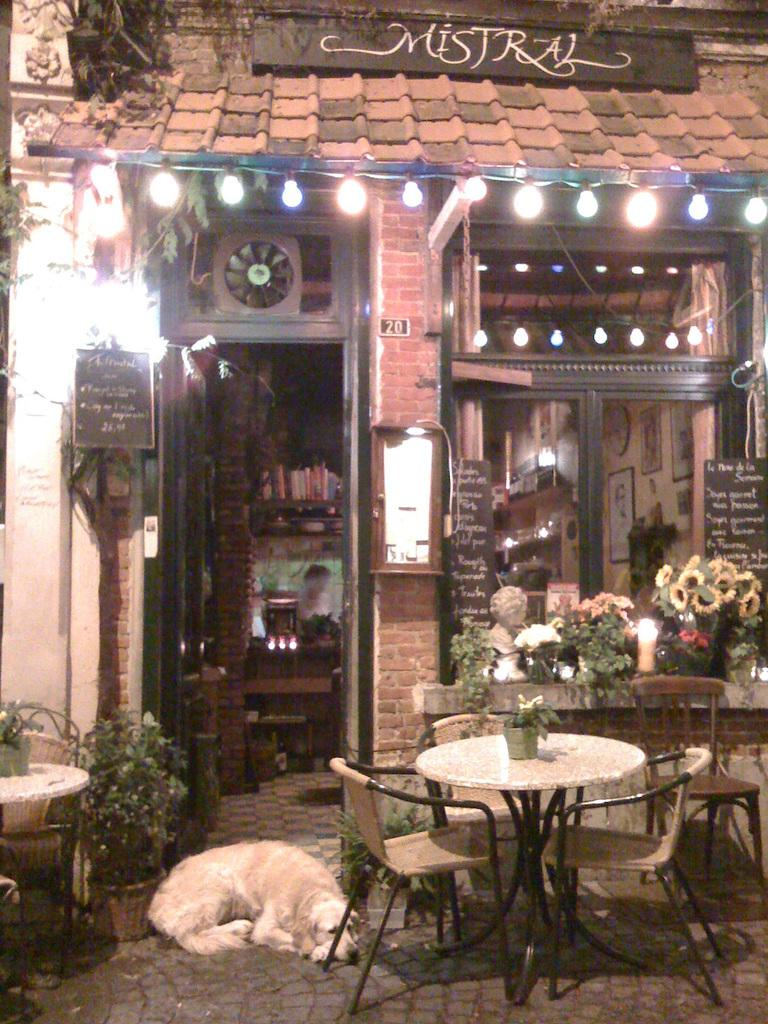What type of establishment is shown in the image? A: There is a store in the image. What furniture is available inside the store? The store has tables and chairs. What is the store's flooring like? The store has floors. Is there any animal present in the image? Yes, there is a dog sleeping in front of the store's door. What type of hose is being used to water the plants in the image? There are no plants or hoses visible in the image; it features a store with a dog sleeping in front of the door. 